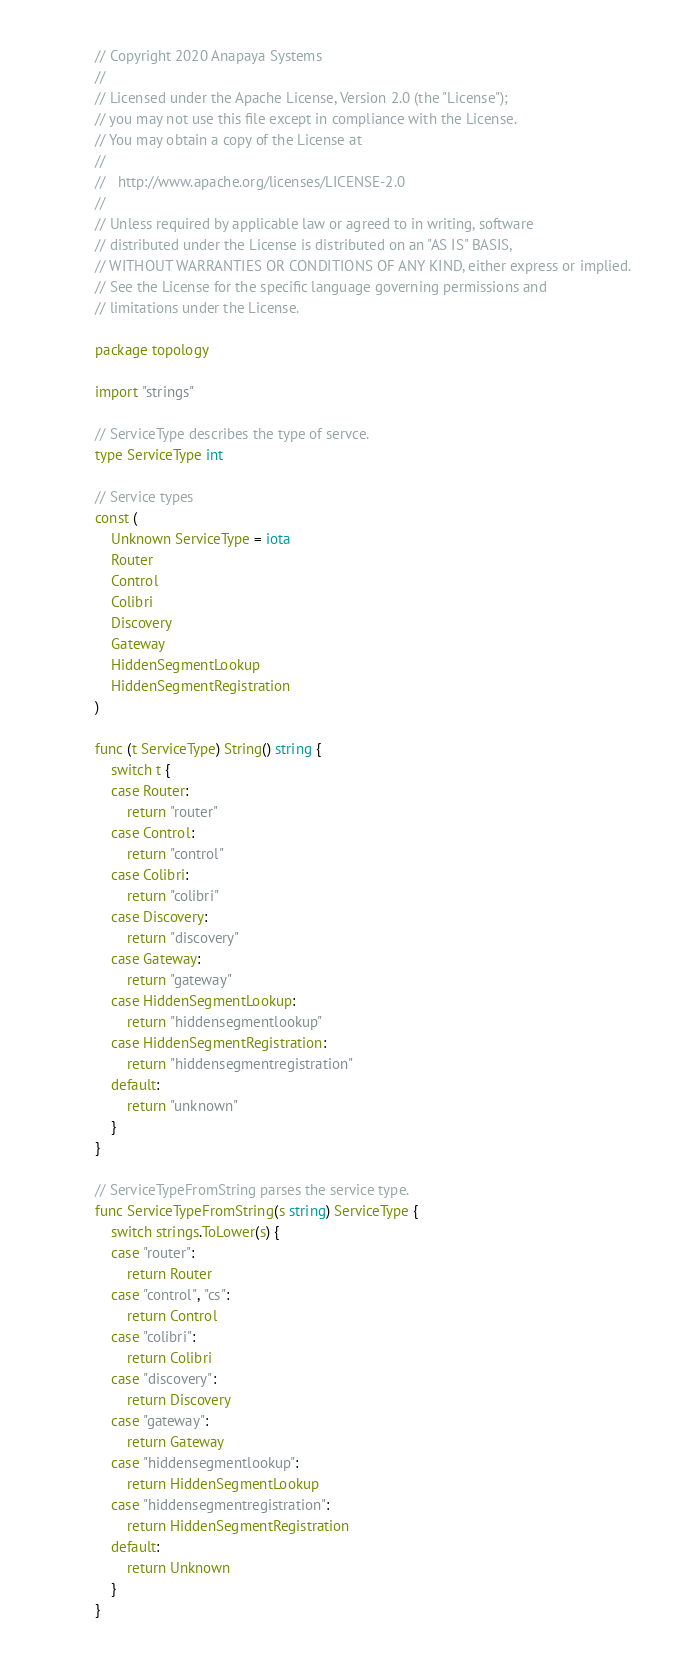<code> <loc_0><loc_0><loc_500><loc_500><_Go_>// Copyright 2020 Anapaya Systems
//
// Licensed under the Apache License, Version 2.0 (the "License");
// you may not use this file except in compliance with the License.
// You may obtain a copy of the License at
//
//   http://www.apache.org/licenses/LICENSE-2.0
//
// Unless required by applicable law or agreed to in writing, software
// distributed under the License is distributed on an "AS IS" BASIS,
// WITHOUT WARRANTIES OR CONDITIONS OF ANY KIND, either express or implied.
// See the License for the specific language governing permissions and
// limitations under the License.

package topology

import "strings"

// ServiceType describes the type of servce.
type ServiceType int

// Service types
const (
	Unknown ServiceType = iota
	Router
	Control
	Colibri
	Discovery
	Gateway
	HiddenSegmentLookup
	HiddenSegmentRegistration
)

func (t ServiceType) String() string {
	switch t {
	case Router:
		return "router"
	case Control:
		return "control"
	case Colibri:
		return "colibri"
	case Discovery:
		return "discovery"
	case Gateway:
		return "gateway"
	case HiddenSegmentLookup:
		return "hiddensegmentlookup"
	case HiddenSegmentRegistration:
		return "hiddensegmentregistration"
	default:
		return "unknown"
	}
}

// ServiceTypeFromString parses the service type.
func ServiceTypeFromString(s string) ServiceType {
	switch strings.ToLower(s) {
	case "router":
		return Router
	case "control", "cs":
		return Control
	case "colibri":
		return Colibri
	case "discovery":
		return Discovery
	case "gateway":
		return Gateway
	case "hiddensegmentlookup":
		return HiddenSegmentLookup
	case "hiddensegmentregistration":
		return HiddenSegmentRegistration
	default:
		return Unknown
	}
}
</code> 